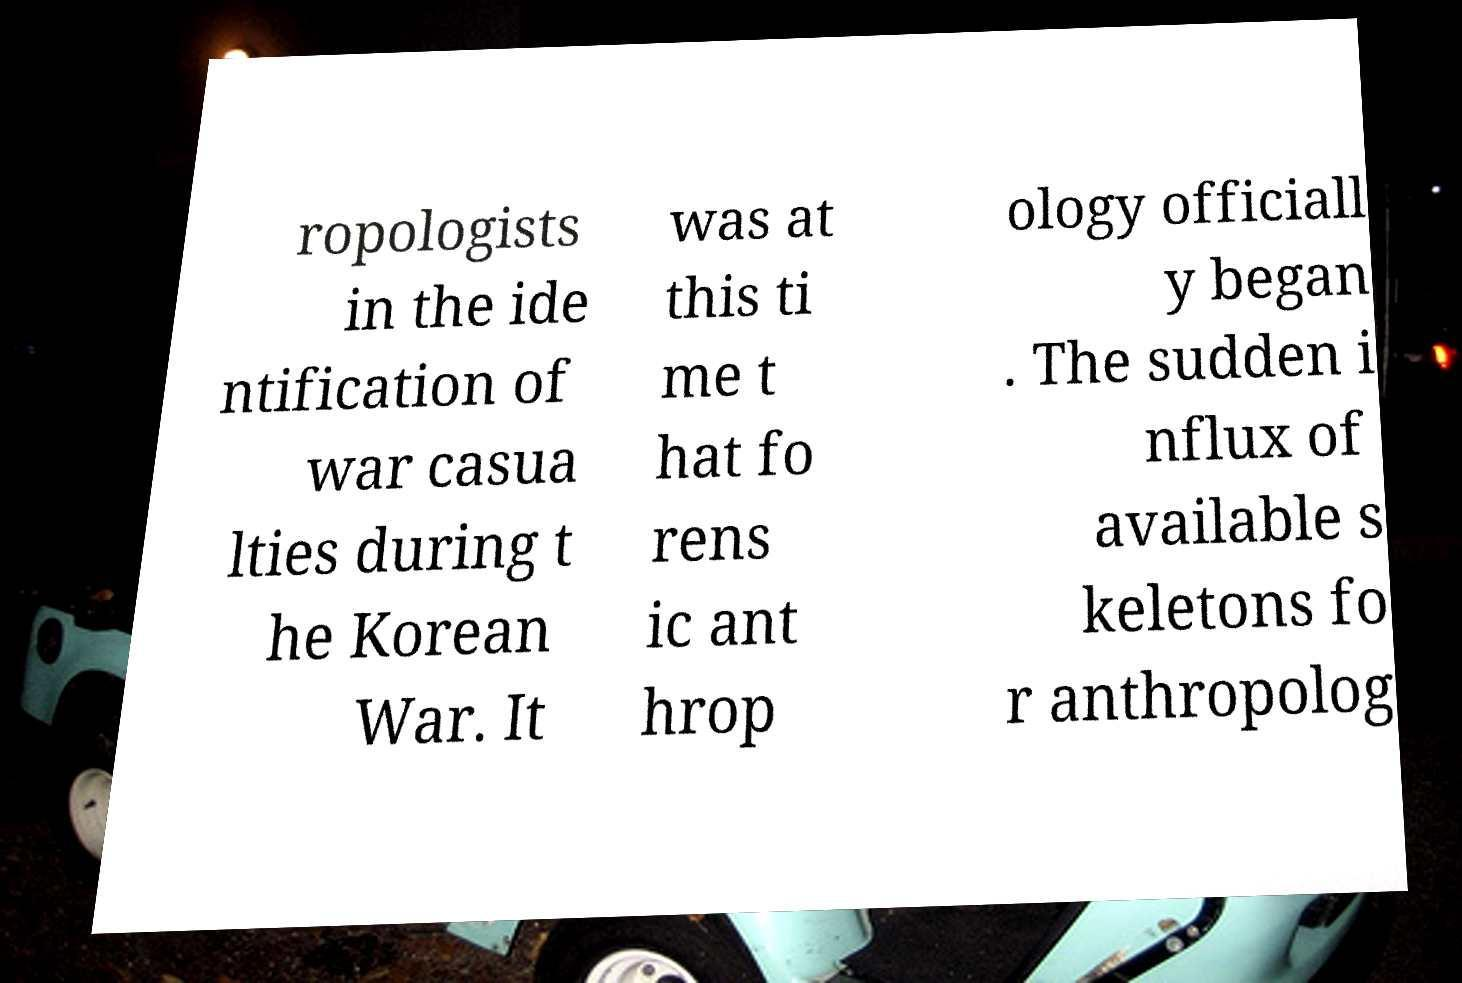Please identify and transcribe the text found in this image. ropologists in the ide ntification of war casua lties during t he Korean War. It was at this ti me t hat fo rens ic ant hrop ology officiall y began . The sudden i nflux of available s keletons fo r anthropolog 